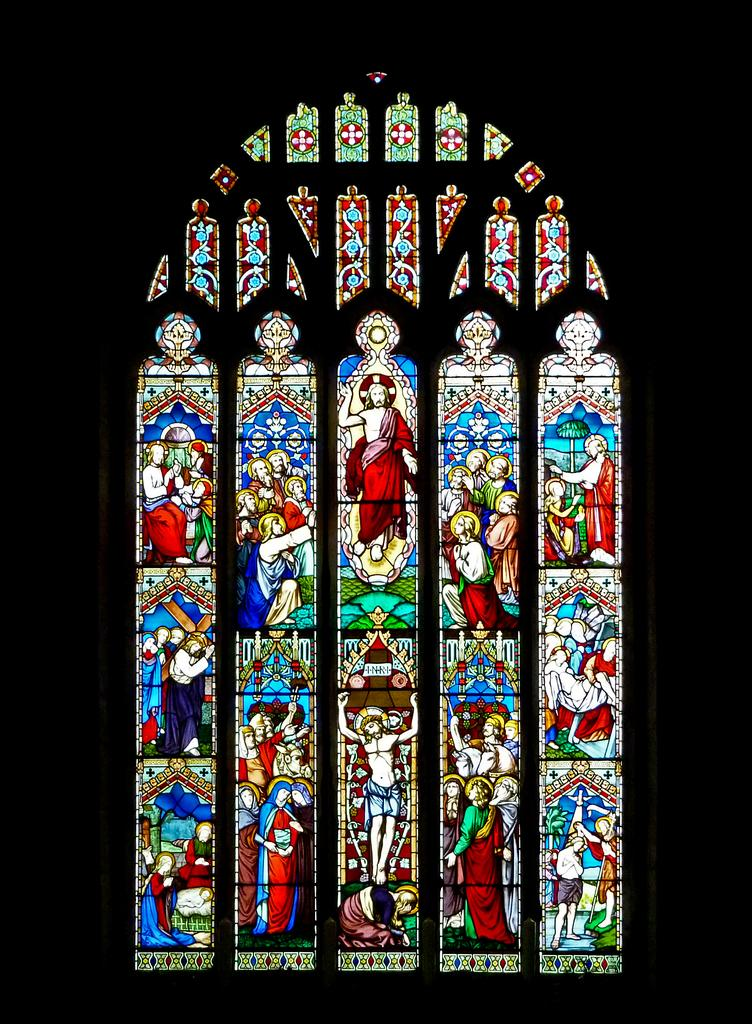What is present on the wall in the image? There are wall paintings in the image. Can you describe the setting of the image? The image may have been taken in a church. What type of account is being discussed in the image? There is no account being discussed in the image; it features a wall with wall paintings in a possible church setting. 